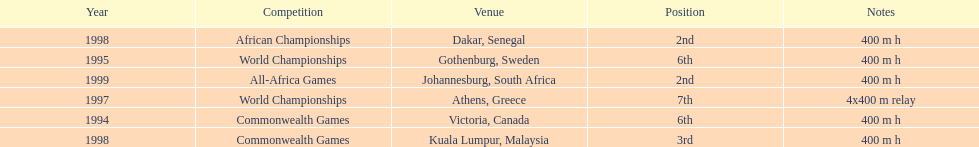What is the name of the last competition? All-Africa Games. 